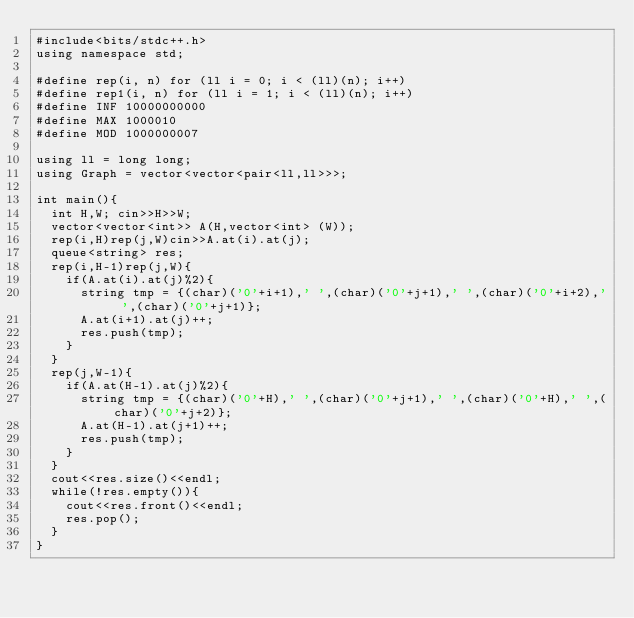<code> <loc_0><loc_0><loc_500><loc_500><_C++_>#include<bits/stdc++.h>
using namespace std;

#define rep(i, n) for (ll i = 0; i < (ll)(n); i++)
#define rep1(i, n) for (ll i = 1; i < (ll)(n); i++)
#define INF 10000000000
#define MAX 1000010
#define MOD 1000000007
  
using ll = long long;
using Graph = vector<vector<pair<ll,ll>>>;

int main(){
  int H,W; cin>>H>>W;
  vector<vector<int>> A(H,vector<int> (W));
  rep(i,H)rep(j,W)cin>>A.at(i).at(j);
  queue<string> res;
  rep(i,H-1)rep(j,W){
    if(A.at(i).at(j)%2){
      string tmp = {(char)('0'+i+1),' ',(char)('0'+j+1),' ',(char)('0'+i+2),' ',(char)('0'+j+1)};
      A.at(i+1).at(j)++;
      res.push(tmp);
    }
  }
  rep(j,W-1){
    if(A.at(H-1).at(j)%2){
      string tmp = {(char)('0'+H),' ',(char)('0'+j+1),' ',(char)('0'+H),' ',(char)('0'+j+2)};
      A.at(H-1).at(j+1)++;
      res.push(tmp);
    }
  }
  cout<<res.size()<<endl;
  while(!res.empty()){
    cout<<res.front()<<endl;
    res.pop();    
  }
}</code> 